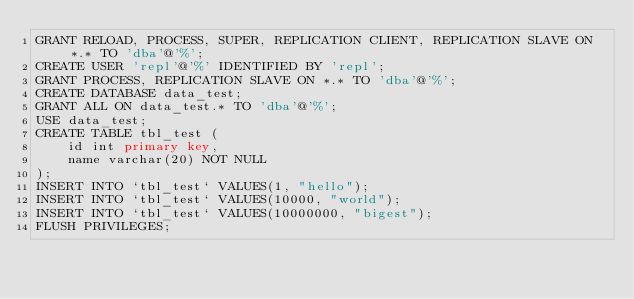Convert code to text. <code><loc_0><loc_0><loc_500><loc_500><_SQL_>GRANT RELOAD, PROCESS, SUPER, REPLICATION CLIENT, REPLICATION SLAVE ON *.* TO 'dba'@'%';
CREATE USER 'repl'@'%' IDENTIFIED BY 'repl';
GRANT PROCESS, REPLICATION SLAVE ON *.* TO 'dba'@'%';
CREATE DATABASE data_test;
GRANT ALL ON data_test.* TO 'dba'@'%';
USE data_test;
CREATE TABLE tbl_test (
    id int primary key,
    name varchar(20) NOT NULL
);
INSERT INTO `tbl_test` VALUES(1, "hello");
INSERT INTO `tbl_test` VALUES(10000, "world");
INSERT INTO `tbl_test` VALUES(10000000, "bigest");
FLUSH PRIVILEGES;
</code> 